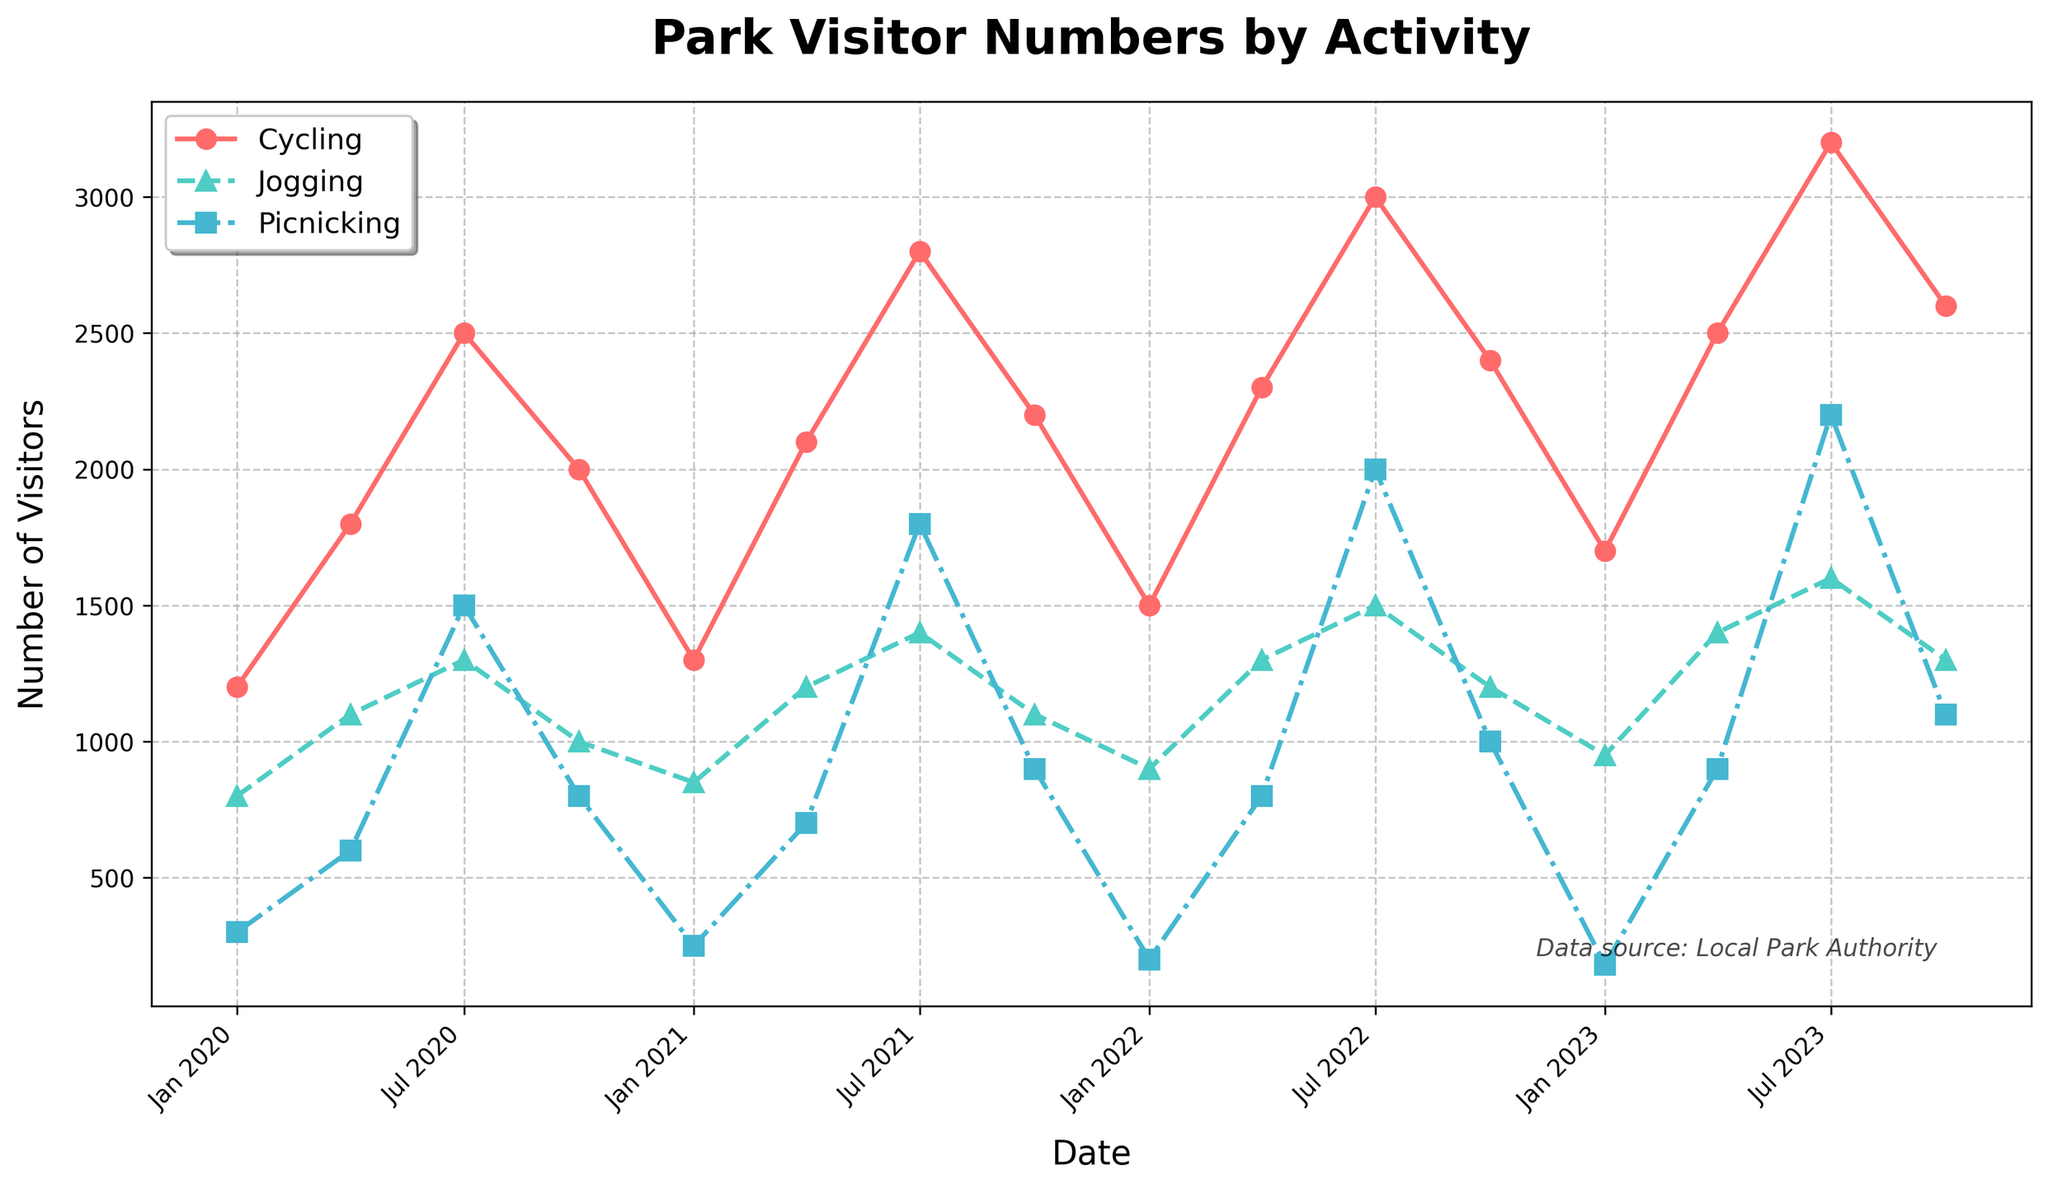What are the months with the highest visitor numbers for cycling and jogging? To find this, look at the peak points on the lines for cycling (red) and jogging (green). The highest visitor numbers for cycling are in July 2023, and for jogging, they are also in July 2023.
Answer: July 2023 Compare the number of visitors for picnicking in July 2023 and April 2023. Which month had more visitors? Check the heights of the lines for picnicking (blue) at the corresponding months. In July 2023, the number of picnickers is higher than in April 2023.
Answer: July 2023 What is the difference in the number of visitors between July 2020 and July 2023 for cycling? Note the values for cycling in July 2020 (2500) and July 2023 (3200). Subtracting these gives the difference: 3200 - 2500 = 700.
Answer: 700 Which month and year saw the lowest number of visitors for picnicking? Look at the lowest points on the picnicking (blue) line. January 2023 had the lowest number of visitors for picnicking.
Answer: January 2023 Between January 2021 and January 2023, what is the average number of visitors for jogging? The visitor numbers in January 2021 are 850 and in January 2023 are 950. The average is (850 + 950) / 2 = 900.
Answer: 900 During which month did all three activities have the highest number of visitors on average? Calculate the average number of visitors for each activity in each month, then pick the month with the highest average. For July 2023: (3200 + 1600 + 2200) / 3 = 2333.3 which seems to be the highest.
Answer: July 2023 How many total visitors were there for jogging in the year 2021? Sum the visitors for jogging in Jan 2021 (850), April 2021 (1200), July 2021 (1400), and October 2021 (1100). 850 + 1200 + 1400 + 1100 = 4550.
Answer: 4550 Do the visitor numbers for picnicking increase consistently over time? Observe the trend line for picnicking (blue). It generally increases but has fluctuations and doesn't always rise consistently month over month.
Answer: No Which activity showed the most significant increase in visitor numbers from April 2022 to July 2022? Compare the upticks for each activity from April 2022 to July 2022. Picnicking saw a significant increase from 800 to 2000.
Answer: Picnicking How did the number of visitors for cycling change from January 2020 to January 2022? Note the visitor numbers for cycling in January 2020 (1200) and January 2022 (1500). The change is 1500 - 1200 = 300.
Answer: Increased by 300 